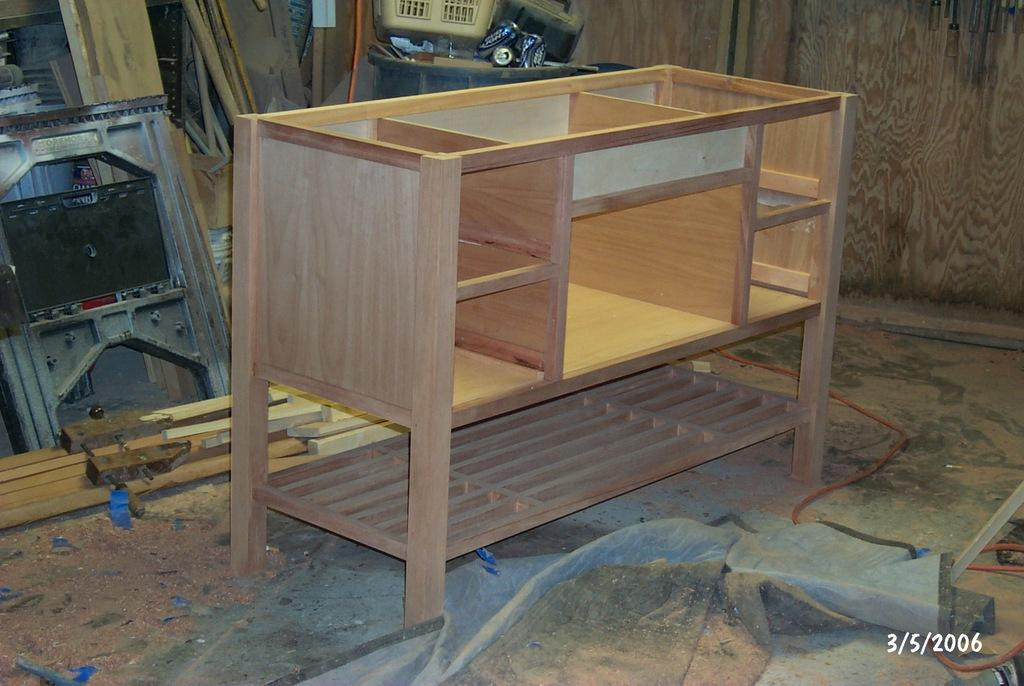What is located in the center of the image? There is a table in the center of the image. What type of material can be seen in the image? Wooden logs are visible in the image. What can be seen in the background of the image? There is equipment in the background of the image. What is present at the bottom of the image? Wires are present at the bottom of the image. What is one of the structural elements in the image? There is a wall in the image. What type of collar can be seen on the wooden logs in the image? There is no collar present on the wooden logs in the image; they are simply logs. 